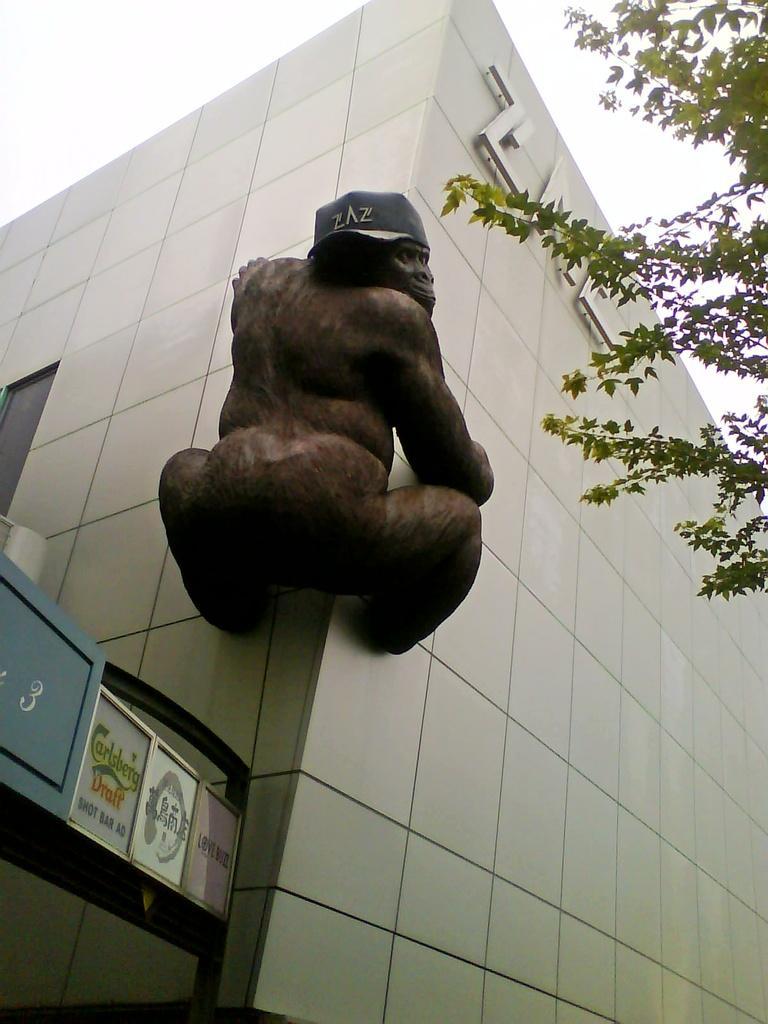Can you describe this image briefly? This image is taken outdoors. On the right side of the image there is a tree. In the middle of the image there is a building and there is a sculpture of a chimpanzee on the wall. On the left side of the image there are a few boards with text on them. 